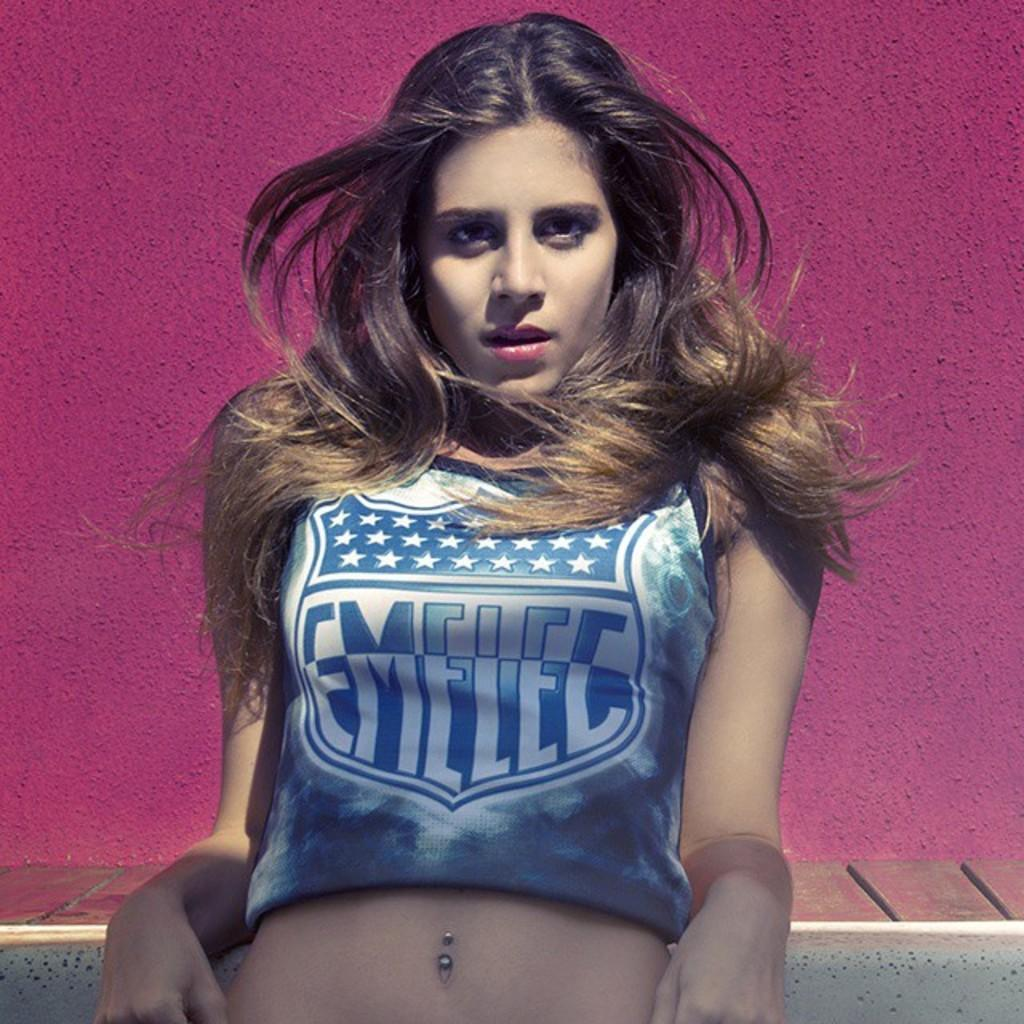<image>
Summarize the visual content of the image. A girl is wearing a shirt that says, 'EMELEC'. 